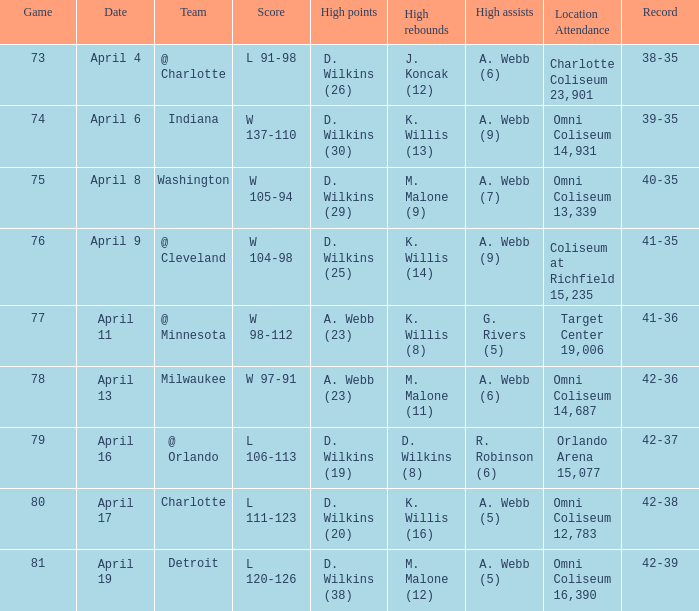Where and with what audience did d. wilkins (29) record the most points? Omni Coliseum 13,339. 